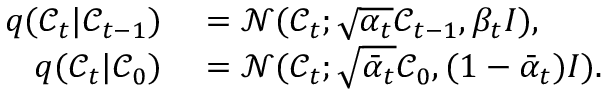<formula> <loc_0><loc_0><loc_500><loc_500>\begin{array} { r l } { q ( \mathcal { C } _ { t } | \mathcal { C } _ { t - 1 } ) } & = \mathcal { N } ( \mathcal { C } _ { t } ; \sqrt { \alpha _ { t } } \mathcal { C } _ { t - 1 } , \beta _ { t } I ) , } \\ { q ( \mathcal { C } _ { t } | \mathcal { C } _ { 0 } ) } & = \mathcal { N } ( \mathcal { C } _ { t } ; \sqrt { \bar { \alpha } _ { t } } \mathcal { C } _ { 0 } , ( 1 - \bar { \alpha } _ { t } ) I ) . } \end{array}</formula> 